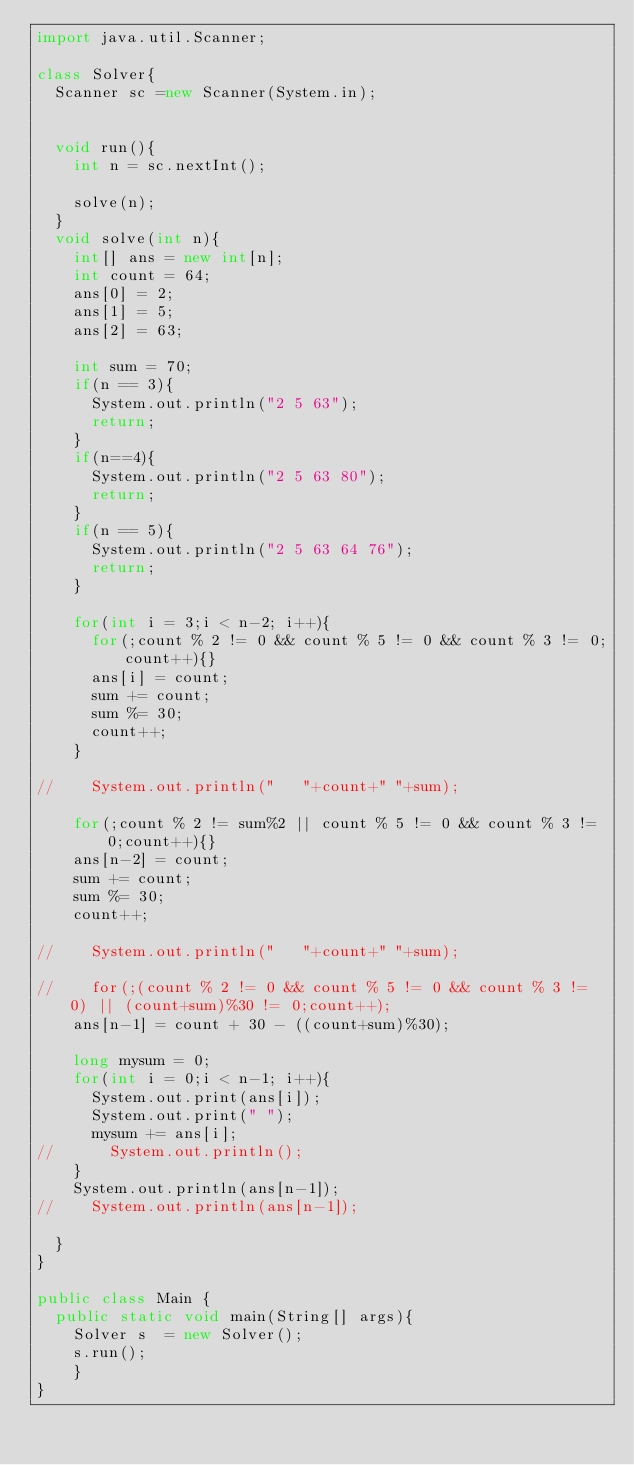Convert code to text. <code><loc_0><loc_0><loc_500><loc_500><_Java_>import java.util.Scanner;

class Solver{
	Scanner sc =new Scanner(System.in);
	
	
	void run(){
		int n = sc.nextInt();
		
		solve(n);
	}
	void solve(int n){
		int[] ans = new int[n];
		int count = 64;
		ans[0] = 2;
		ans[1] = 5;
		ans[2] = 63;
		
		int sum = 70;
		if(n == 3){
			System.out.println("2 5 63");
			return;
		}
		if(n==4){
			System.out.println("2 5 63 80");
			return;
		}
		if(n == 5){
			System.out.println("2 5 63 64 76");
			return;
		}
		
		for(int i = 3;i < n-2; i++){
			for(;count % 2 != 0 && count % 5 != 0 && count % 3 != 0;count++){}
			ans[i] = count;
			sum += count;
			sum %= 30;
			count++;
		}

//		System.out.println("   "+count+" "+sum);

		for(;count % 2 != sum%2 || count % 5 != 0 && count % 3 != 0;count++){}
		ans[n-2] = count;
		sum += count;
		sum %= 30;
		count++;
		
//		System.out.println("   "+count+" "+sum);
		
//		for(;(count % 2 != 0 && count % 5 != 0 && count % 3 != 0) || (count+sum)%30 != 0;count++);
		ans[n-1] = count + 30 - ((count+sum)%30);
		
		long mysum = 0;
		for(int i = 0;i < n-1; i++){
			System.out.print(ans[i]);
			System.out.print(" ");
			mysum += ans[i];
//			System.out.println();
		}
		System.out.println(ans[n-1]);
//		System.out.println(ans[n-1]);
		
	}
}

public class Main {
	public static void main(String[] args){
		Solver s  = new Solver();
		s.run();
		}
}</code> 